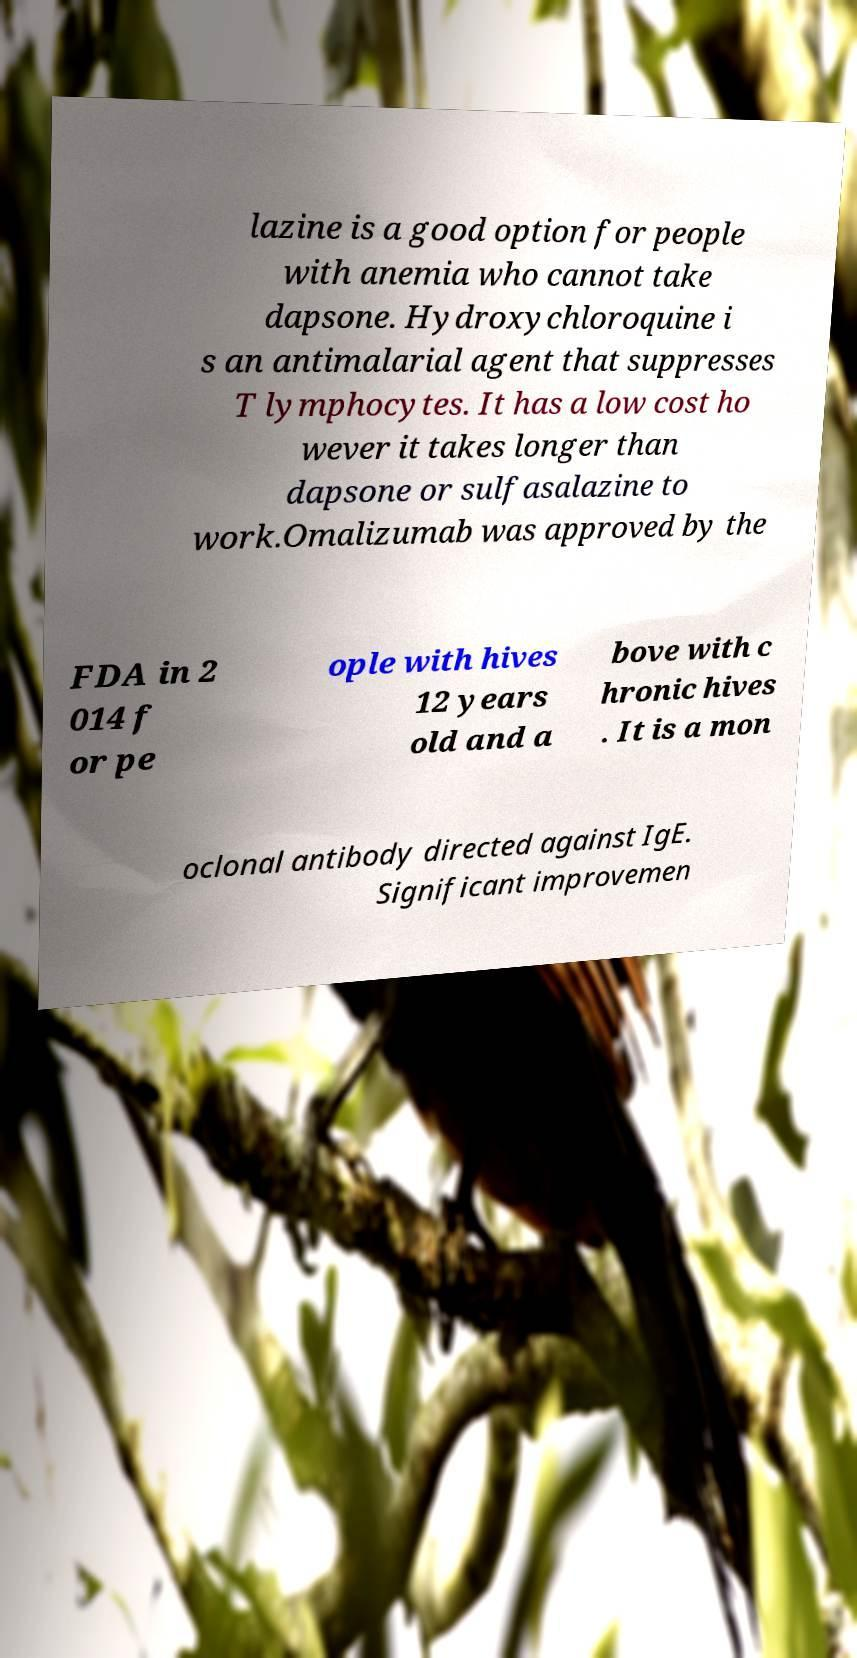Could you extract and type out the text from this image? lazine is a good option for people with anemia who cannot take dapsone. Hydroxychloroquine i s an antimalarial agent that suppresses T lymphocytes. It has a low cost ho wever it takes longer than dapsone or sulfasalazine to work.Omalizumab was approved by the FDA in 2 014 f or pe ople with hives 12 years old and a bove with c hronic hives . It is a mon oclonal antibody directed against IgE. Significant improvemen 